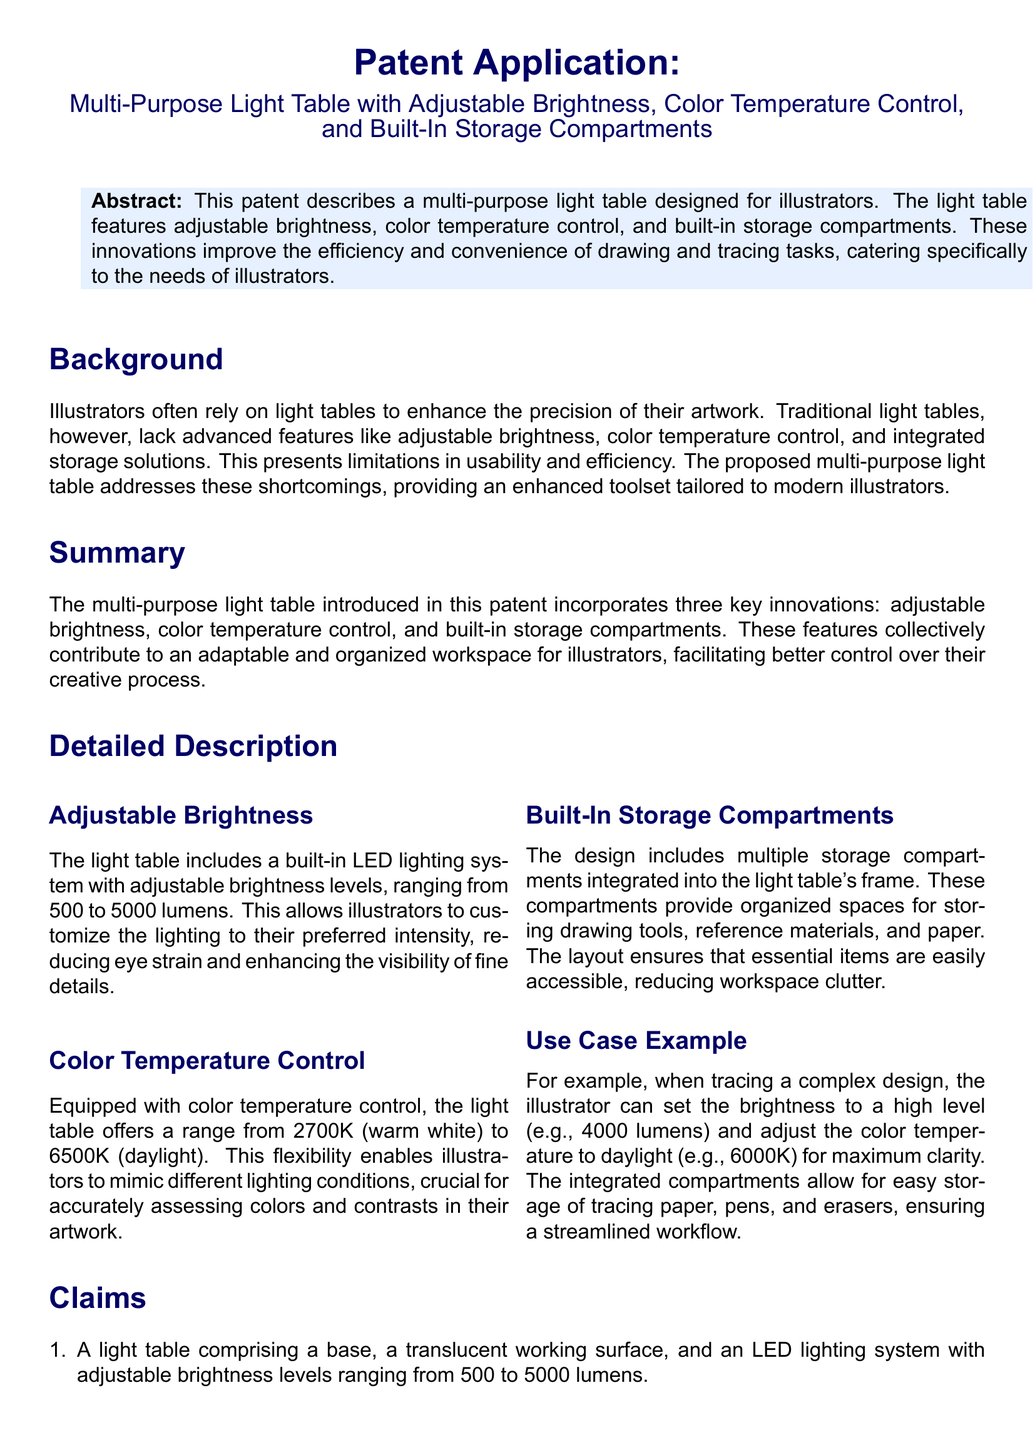what are the main features of the light table? The main features include adjustable brightness, color temperature control, and built-in storage compartments.
Answer: adjustable brightness, color temperature control, built-in storage compartments what is the brightness range? The brightness range of the light table is specified in lumens, from 500 to 5000 lumens.
Answer: 500 to 5000 lumens what is the color temperature range? The color temperature range of the light table is between 2700K and 6500K.
Answer: 2700K to 6500K what are the integrated storage compartments used for? The built-in storage compartments are designed for organizing drawing tools and materials.
Answer: organizing drawing tools and materials how does the adjustable brightness benefit illustrators? Adjustable brightness helps reduce eye strain and enhances visibility of fine details for illustrators.
Answer: reduces eye strain, enhances visibility what is the use case example for the light table? The example describes adjusting brightness to 4000 lumens and color temperature to 6000K for tracing designs.
Answer: 4000 lumens, 6000K what is the purpose of color temperature control? Color temperature control allows illustrators to mimic different lighting conditions for better color assessment.
Answer: mimic different lighting conditions what is the document type? This document is a patent application.
Answer: patent application how many claims are presented in the document? The document contains a total of three claims regarding the light table's features.
Answer: three claims 